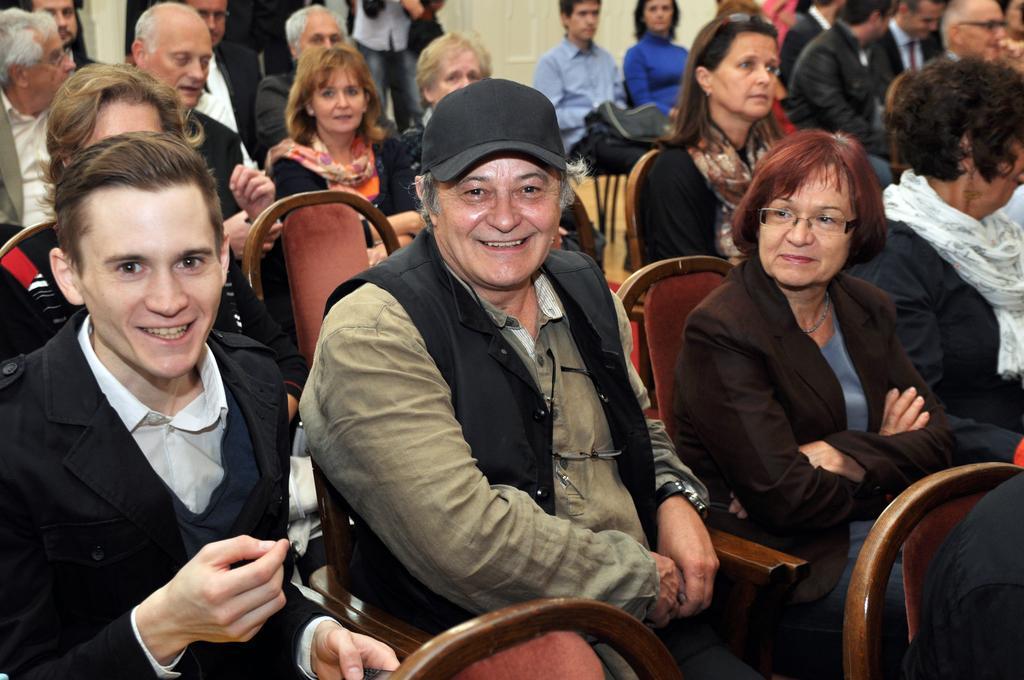Describe this image in one or two sentences. This image in a room. There are many people in this room. In the left side of the image there is a man sitting on a chair. In the middle of the image a wearing a hat is sitting on a chair. In the right side of the image a woman is sitting on a chair. At the top right of the image few people are sitting on a chair. 